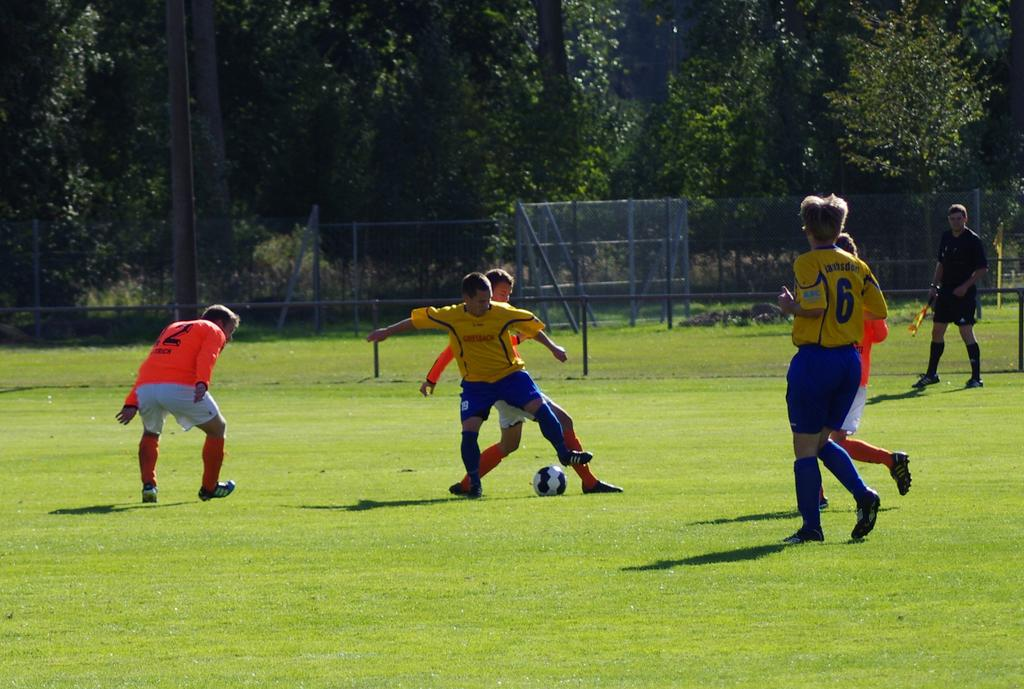Provide a one-sentence caption for the provided image. Players on the soccer field one with 6 on their shirt. 